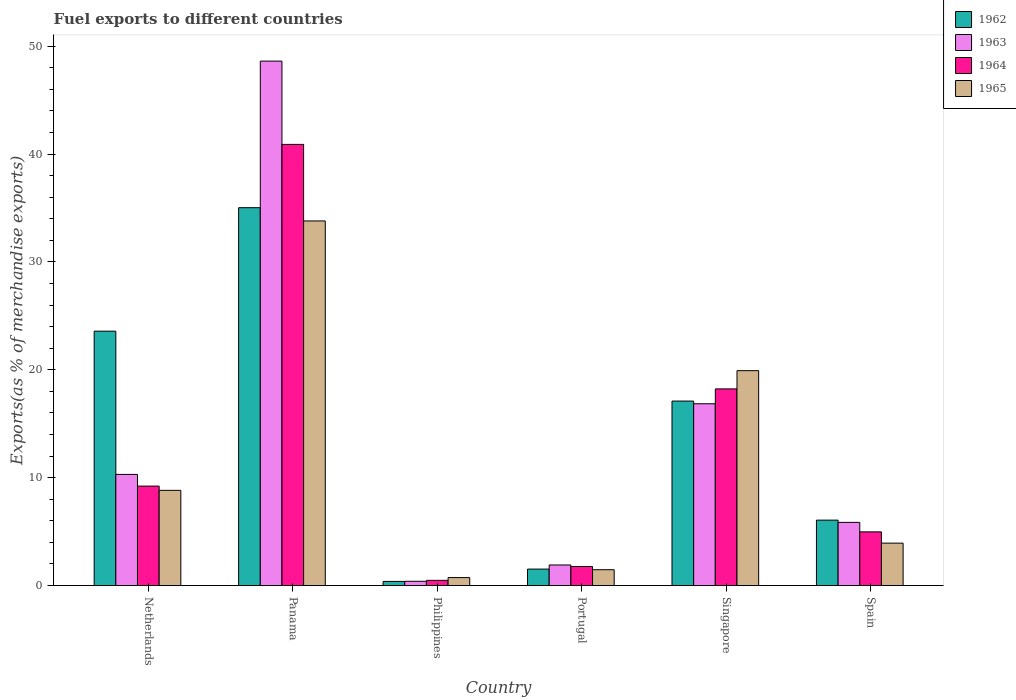How many groups of bars are there?
Your answer should be very brief. 6. Are the number of bars per tick equal to the number of legend labels?
Make the answer very short. Yes. How many bars are there on the 6th tick from the left?
Offer a terse response. 4. What is the label of the 6th group of bars from the left?
Make the answer very short. Spain. What is the percentage of exports to different countries in 1963 in Spain?
Provide a succinct answer. 5.86. Across all countries, what is the maximum percentage of exports to different countries in 1962?
Your answer should be very brief. 35.03. Across all countries, what is the minimum percentage of exports to different countries in 1963?
Keep it short and to the point. 0.4. In which country was the percentage of exports to different countries in 1964 maximum?
Keep it short and to the point. Panama. In which country was the percentage of exports to different countries in 1962 minimum?
Your answer should be very brief. Philippines. What is the total percentage of exports to different countries in 1962 in the graph?
Keep it short and to the point. 83.7. What is the difference between the percentage of exports to different countries in 1965 in Singapore and that in Spain?
Your answer should be very brief. 15.99. What is the difference between the percentage of exports to different countries in 1964 in Portugal and the percentage of exports to different countries in 1965 in Singapore?
Give a very brief answer. -18.16. What is the average percentage of exports to different countries in 1964 per country?
Offer a very short reply. 12.6. What is the difference between the percentage of exports to different countries of/in 1965 and percentage of exports to different countries of/in 1964 in Netherlands?
Ensure brevity in your answer.  -0.39. In how many countries, is the percentage of exports to different countries in 1965 greater than 32 %?
Your response must be concise. 1. What is the ratio of the percentage of exports to different countries in 1963 in Panama to that in Singapore?
Provide a succinct answer. 2.88. Is the difference between the percentage of exports to different countries in 1965 in Philippines and Spain greater than the difference between the percentage of exports to different countries in 1964 in Philippines and Spain?
Make the answer very short. Yes. What is the difference between the highest and the second highest percentage of exports to different countries in 1964?
Give a very brief answer. 31.68. What is the difference between the highest and the lowest percentage of exports to different countries in 1965?
Your response must be concise. 33.06. In how many countries, is the percentage of exports to different countries in 1965 greater than the average percentage of exports to different countries in 1965 taken over all countries?
Your answer should be compact. 2. Is it the case that in every country, the sum of the percentage of exports to different countries in 1962 and percentage of exports to different countries in 1964 is greater than the sum of percentage of exports to different countries in 1965 and percentage of exports to different countries in 1963?
Offer a terse response. No. What does the 3rd bar from the left in Netherlands represents?
Offer a very short reply. 1964. Is it the case that in every country, the sum of the percentage of exports to different countries in 1962 and percentage of exports to different countries in 1964 is greater than the percentage of exports to different countries in 1963?
Your answer should be compact. Yes. How many bars are there?
Your answer should be very brief. 24. What is the difference between two consecutive major ticks on the Y-axis?
Your response must be concise. 10. Does the graph contain grids?
Give a very brief answer. No. What is the title of the graph?
Offer a terse response. Fuel exports to different countries. What is the label or title of the X-axis?
Your answer should be very brief. Country. What is the label or title of the Y-axis?
Your answer should be compact. Exports(as % of merchandise exports). What is the Exports(as % of merchandise exports) in 1962 in Netherlands?
Offer a terse response. 23.58. What is the Exports(as % of merchandise exports) in 1963 in Netherlands?
Your answer should be compact. 10.31. What is the Exports(as % of merchandise exports) in 1964 in Netherlands?
Keep it short and to the point. 9.22. What is the Exports(as % of merchandise exports) of 1965 in Netherlands?
Ensure brevity in your answer.  8.83. What is the Exports(as % of merchandise exports) in 1962 in Panama?
Provide a short and direct response. 35.03. What is the Exports(as % of merchandise exports) of 1963 in Panama?
Provide a short and direct response. 48.62. What is the Exports(as % of merchandise exports) in 1964 in Panama?
Offer a very short reply. 40.9. What is the Exports(as % of merchandise exports) of 1965 in Panama?
Provide a short and direct response. 33.8. What is the Exports(as % of merchandise exports) of 1962 in Philippines?
Your response must be concise. 0.38. What is the Exports(as % of merchandise exports) of 1963 in Philippines?
Offer a terse response. 0.4. What is the Exports(as % of merchandise exports) in 1964 in Philippines?
Your answer should be compact. 0.48. What is the Exports(as % of merchandise exports) of 1965 in Philippines?
Offer a terse response. 0.74. What is the Exports(as % of merchandise exports) in 1962 in Portugal?
Make the answer very short. 1.53. What is the Exports(as % of merchandise exports) of 1963 in Portugal?
Your answer should be very brief. 1.91. What is the Exports(as % of merchandise exports) in 1964 in Portugal?
Provide a succinct answer. 1.77. What is the Exports(as % of merchandise exports) of 1965 in Portugal?
Offer a very short reply. 1.47. What is the Exports(as % of merchandise exports) of 1962 in Singapore?
Your answer should be compact. 17.1. What is the Exports(as % of merchandise exports) in 1963 in Singapore?
Ensure brevity in your answer.  16.85. What is the Exports(as % of merchandise exports) of 1964 in Singapore?
Keep it short and to the point. 18.23. What is the Exports(as % of merchandise exports) in 1965 in Singapore?
Keep it short and to the point. 19.92. What is the Exports(as % of merchandise exports) in 1962 in Spain?
Your response must be concise. 6.07. What is the Exports(as % of merchandise exports) in 1963 in Spain?
Offer a very short reply. 5.86. What is the Exports(as % of merchandise exports) in 1964 in Spain?
Give a very brief answer. 4.98. What is the Exports(as % of merchandise exports) of 1965 in Spain?
Ensure brevity in your answer.  3.93. Across all countries, what is the maximum Exports(as % of merchandise exports) of 1962?
Give a very brief answer. 35.03. Across all countries, what is the maximum Exports(as % of merchandise exports) in 1963?
Your answer should be compact. 48.62. Across all countries, what is the maximum Exports(as % of merchandise exports) in 1964?
Your answer should be very brief. 40.9. Across all countries, what is the maximum Exports(as % of merchandise exports) of 1965?
Keep it short and to the point. 33.8. Across all countries, what is the minimum Exports(as % of merchandise exports) of 1962?
Your answer should be very brief. 0.38. Across all countries, what is the minimum Exports(as % of merchandise exports) in 1963?
Provide a succinct answer. 0.4. Across all countries, what is the minimum Exports(as % of merchandise exports) of 1964?
Give a very brief answer. 0.48. Across all countries, what is the minimum Exports(as % of merchandise exports) of 1965?
Provide a short and direct response. 0.74. What is the total Exports(as % of merchandise exports) in 1962 in the graph?
Give a very brief answer. 83.7. What is the total Exports(as % of merchandise exports) in 1963 in the graph?
Your answer should be very brief. 83.94. What is the total Exports(as % of merchandise exports) in 1964 in the graph?
Your response must be concise. 75.58. What is the total Exports(as % of merchandise exports) of 1965 in the graph?
Ensure brevity in your answer.  68.69. What is the difference between the Exports(as % of merchandise exports) in 1962 in Netherlands and that in Panama?
Provide a succinct answer. -11.45. What is the difference between the Exports(as % of merchandise exports) in 1963 in Netherlands and that in Panama?
Make the answer very short. -38.32. What is the difference between the Exports(as % of merchandise exports) of 1964 in Netherlands and that in Panama?
Provide a succinct answer. -31.68. What is the difference between the Exports(as % of merchandise exports) in 1965 in Netherlands and that in Panama?
Your answer should be very brief. -24.98. What is the difference between the Exports(as % of merchandise exports) in 1962 in Netherlands and that in Philippines?
Provide a succinct answer. 23.2. What is the difference between the Exports(as % of merchandise exports) in 1963 in Netherlands and that in Philippines?
Offer a very short reply. 9.91. What is the difference between the Exports(as % of merchandise exports) of 1964 in Netherlands and that in Philippines?
Keep it short and to the point. 8.74. What is the difference between the Exports(as % of merchandise exports) in 1965 in Netherlands and that in Philippines?
Provide a succinct answer. 8.09. What is the difference between the Exports(as % of merchandise exports) in 1962 in Netherlands and that in Portugal?
Provide a short and direct response. 22.06. What is the difference between the Exports(as % of merchandise exports) of 1963 in Netherlands and that in Portugal?
Your answer should be compact. 8.4. What is the difference between the Exports(as % of merchandise exports) in 1964 in Netherlands and that in Portugal?
Your response must be concise. 7.45. What is the difference between the Exports(as % of merchandise exports) of 1965 in Netherlands and that in Portugal?
Make the answer very short. 7.36. What is the difference between the Exports(as % of merchandise exports) of 1962 in Netherlands and that in Singapore?
Your answer should be compact. 6.48. What is the difference between the Exports(as % of merchandise exports) of 1963 in Netherlands and that in Singapore?
Offer a very short reply. -6.55. What is the difference between the Exports(as % of merchandise exports) of 1964 in Netherlands and that in Singapore?
Give a very brief answer. -9.01. What is the difference between the Exports(as % of merchandise exports) of 1965 in Netherlands and that in Singapore?
Offer a very short reply. -11.1. What is the difference between the Exports(as % of merchandise exports) in 1962 in Netherlands and that in Spain?
Provide a short and direct response. 17.52. What is the difference between the Exports(as % of merchandise exports) of 1963 in Netherlands and that in Spain?
Ensure brevity in your answer.  4.45. What is the difference between the Exports(as % of merchandise exports) in 1964 in Netherlands and that in Spain?
Provide a succinct answer. 4.24. What is the difference between the Exports(as % of merchandise exports) in 1965 in Netherlands and that in Spain?
Ensure brevity in your answer.  4.89. What is the difference between the Exports(as % of merchandise exports) of 1962 in Panama and that in Philippines?
Give a very brief answer. 34.65. What is the difference between the Exports(as % of merchandise exports) in 1963 in Panama and that in Philippines?
Provide a succinct answer. 48.22. What is the difference between the Exports(as % of merchandise exports) of 1964 in Panama and that in Philippines?
Give a very brief answer. 40.41. What is the difference between the Exports(as % of merchandise exports) of 1965 in Panama and that in Philippines?
Your response must be concise. 33.06. What is the difference between the Exports(as % of merchandise exports) in 1962 in Panama and that in Portugal?
Make the answer very short. 33.5. What is the difference between the Exports(as % of merchandise exports) in 1963 in Panama and that in Portugal?
Your answer should be very brief. 46.71. What is the difference between the Exports(as % of merchandise exports) in 1964 in Panama and that in Portugal?
Make the answer very short. 39.13. What is the difference between the Exports(as % of merchandise exports) in 1965 in Panama and that in Portugal?
Give a very brief answer. 32.33. What is the difference between the Exports(as % of merchandise exports) in 1962 in Panama and that in Singapore?
Offer a very short reply. 17.93. What is the difference between the Exports(as % of merchandise exports) in 1963 in Panama and that in Singapore?
Your answer should be very brief. 31.77. What is the difference between the Exports(as % of merchandise exports) of 1964 in Panama and that in Singapore?
Make the answer very short. 22.67. What is the difference between the Exports(as % of merchandise exports) in 1965 in Panama and that in Singapore?
Keep it short and to the point. 13.88. What is the difference between the Exports(as % of merchandise exports) of 1962 in Panama and that in Spain?
Provide a succinct answer. 28.96. What is the difference between the Exports(as % of merchandise exports) in 1963 in Panama and that in Spain?
Provide a short and direct response. 42.76. What is the difference between the Exports(as % of merchandise exports) of 1964 in Panama and that in Spain?
Your answer should be compact. 35.92. What is the difference between the Exports(as % of merchandise exports) in 1965 in Panama and that in Spain?
Keep it short and to the point. 29.87. What is the difference between the Exports(as % of merchandise exports) of 1962 in Philippines and that in Portugal?
Keep it short and to the point. -1.14. What is the difference between the Exports(as % of merchandise exports) of 1963 in Philippines and that in Portugal?
Your answer should be compact. -1.51. What is the difference between the Exports(as % of merchandise exports) in 1964 in Philippines and that in Portugal?
Your response must be concise. -1.28. What is the difference between the Exports(as % of merchandise exports) in 1965 in Philippines and that in Portugal?
Your answer should be very brief. -0.73. What is the difference between the Exports(as % of merchandise exports) of 1962 in Philippines and that in Singapore?
Make the answer very short. -16.72. What is the difference between the Exports(as % of merchandise exports) in 1963 in Philippines and that in Singapore?
Provide a short and direct response. -16.46. What is the difference between the Exports(as % of merchandise exports) of 1964 in Philippines and that in Singapore?
Offer a terse response. -17.75. What is the difference between the Exports(as % of merchandise exports) in 1965 in Philippines and that in Singapore?
Provide a short and direct response. -19.18. What is the difference between the Exports(as % of merchandise exports) of 1962 in Philippines and that in Spain?
Offer a terse response. -5.68. What is the difference between the Exports(as % of merchandise exports) of 1963 in Philippines and that in Spain?
Keep it short and to the point. -5.46. What is the difference between the Exports(as % of merchandise exports) of 1964 in Philippines and that in Spain?
Your answer should be very brief. -4.49. What is the difference between the Exports(as % of merchandise exports) in 1965 in Philippines and that in Spain?
Your response must be concise. -3.19. What is the difference between the Exports(as % of merchandise exports) in 1962 in Portugal and that in Singapore?
Offer a very short reply. -15.58. What is the difference between the Exports(as % of merchandise exports) in 1963 in Portugal and that in Singapore?
Keep it short and to the point. -14.95. What is the difference between the Exports(as % of merchandise exports) of 1964 in Portugal and that in Singapore?
Offer a very short reply. -16.47. What is the difference between the Exports(as % of merchandise exports) in 1965 in Portugal and that in Singapore?
Provide a succinct answer. -18.45. What is the difference between the Exports(as % of merchandise exports) in 1962 in Portugal and that in Spain?
Offer a very short reply. -4.54. What is the difference between the Exports(as % of merchandise exports) in 1963 in Portugal and that in Spain?
Your answer should be compact. -3.95. What is the difference between the Exports(as % of merchandise exports) of 1964 in Portugal and that in Spain?
Provide a short and direct response. -3.21. What is the difference between the Exports(as % of merchandise exports) of 1965 in Portugal and that in Spain?
Ensure brevity in your answer.  -2.46. What is the difference between the Exports(as % of merchandise exports) in 1962 in Singapore and that in Spain?
Offer a terse response. 11.04. What is the difference between the Exports(as % of merchandise exports) in 1963 in Singapore and that in Spain?
Offer a terse response. 11. What is the difference between the Exports(as % of merchandise exports) of 1964 in Singapore and that in Spain?
Your answer should be compact. 13.25. What is the difference between the Exports(as % of merchandise exports) of 1965 in Singapore and that in Spain?
Your answer should be very brief. 15.99. What is the difference between the Exports(as % of merchandise exports) in 1962 in Netherlands and the Exports(as % of merchandise exports) in 1963 in Panama?
Offer a very short reply. -25.04. What is the difference between the Exports(as % of merchandise exports) in 1962 in Netherlands and the Exports(as % of merchandise exports) in 1964 in Panama?
Offer a very short reply. -17.31. What is the difference between the Exports(as % of merchandise exports) of 1962 in Netherlands and the Exports(as % of merchandise exports) of 1965 in Panama?
Offer a very short reply. -10.22. What is the difference between the Exports(as % of merchandise exports) of 1963 in Netherlands and the Exports(as % of merchandise exports) of 1964 in Panama?
Ensure brevity in your answer.  -30.59. What is the difference between the Exports(as % of merchandise exports) of 1963 in Netherlands and the Exports(as % of merchandise exports) of 1965 in Panama?
Ensure brevity in your answer.  -23.5. What is the difference between the Exports(as % of merchandise exports) of 1964 in Netherlands and the Exports(as % of merchandise exports) of 1965 in Panama?
Give a very brief answer. -24.58. What is the difference between the Exports(as % of merchandise exports) of 1962 in Netherlands and the Exports(as % of merchandise exports) of 1963 in Philippines?
Your response must be concise. 23.19. What is the difference between the Exports(as % of merchandise exports) of 1962 in Netherlands and the Exports(as % of merchandise exports) of 1964 in Philippines?
Ensure brevity in your answer.  23.1. What is the difference between the Exports(as % of merchandise exports) of 1962 in Netherlands and the Exports(as % of merchandise exports) of 1965 in Philippines?
Give a very brief answer. 22.84. What is the difference between the Exports(as % of merchandise exports) in 1963 in Netherlands and the Exports(as % of merchandise exports) in 1964 in Philippines?
Make the answer very short. 9.82. What is the difference between the Exports(as % of merchandise exports) of 1963 in Netherlands and the Exports(as % of merchandise exports) of 1965 in Philippines?
Keep it short and to the point. 9.57. What is the difference between the Exports(as % of merchandise exports) of 1964 in Netherlands and the Exports(as % of merchandise exports) of 1965 in Philippines?
Keep it short and to the point. 8.48. What is the difference between the Exports(as % of merchandise exports) in 1962 in Netherlands and the Exports(as % of merchandise exports) in 1963 in Portugal?
Offer a very short reply. 21.68. What is the difference between the Exports(as % of merchandise exports) of 1962 in Netherlands and the Exports(as % of merchandise exports) of 1964 in Portugal?
Give a very brief answer. 21.82. What is the difference between the Exports(as % of merchandise exports) of 1962 in Netherlands and the Exports(as % of merchandise exports) of 1965 in Portugal?
Offer a terse response. 22.11. What is the difference between the Exports(as % of merchandise exports) of 1963 in Netherlands and the Exports(as % of merchandise exports) of 1964 in Portugal?
Offer a very short reply. 8.54. What is the difference between the Exports(as % of merchandise exports) of 1963 in Netherlands and the Exports(as % of merchandise exports) of 1965 in Portugal?
Your answer should be compact. 8.84. What is the difference between the Exports(as % of merchandise exports) of 1964 in Netherlands and the Exports(as % of merchandise exports) of 1965 in Portugal?
Ensure brevity in your answer.  7.75. What is the difference between the Exports(as % of merchandise exports) of 1962 in Netherlands and the Exports(as % of merchandise exports) of 1963 in Singapore?
Your answer should be compact. 6.73. What is the difference between the Exports(as % of merchandise exports) in 1962 in Netherlands and the Exports(as % of merchandise exports) in 1964 in Singapore?
Provide a short and direct response. 5.35. What is the difference between the Exports(as % of merchandise exports) in 1962 in Netherlands and the Exports(as % of merchandise exports) in 1965 in Singapore?
Provide a short and direct response. 3.66. What is the difference between the Exports(as % of merchandise exports) in 1963 in Netherlands and the Exports(as % of merchandise exports) in 1964 in Singapore?
Provide a short and direct response. -7.93. What is the difference between the Exports(as % of merchandise exports) of 1963 in Netherlands and the Exports(as % of merchandise exports) of 1965 in Singapore?
Make the answer very short. -9.62. What is the difference between the Exports(as % of merchandise exports) of 1964 in Netherlands and the Exports(as % of merchandise exports) of 1965 in Singapore?
Your answer should be very brief. -10.7. What is the difference between the Exports(as % of merchandise exports) of 1962 in Netherlands and the Exports(as % of merchandise exports) of 1963 in Spain?
Give a very brief answer. 17.73. What is the difference between the Exports(as % of merchandise exports) of 1962 in Netherlands and the Exports(as % of merchandise exports) of 1964 in Spain?
Provide a short and direct response. 18.61. What is the difference between the Exports(as % of merchandise exports) in 1962 in Netherlands and the Exports(as % of merchandise exports) in 1965 in Spain?
Provide a succinct answer. 19.65. What is the difference between the Exports(as % of merchandise exports) in 1963 in Netherlands and the Exports(as % of merchandise exports) in 1964 in Spain?
Provide a short and direct response. 5.33. What is the difference between the Exports(as % of merchandise exports) of 1963 in Netherlands and the Exports(as % of merchandise exports) of 1965 in Spain?
Keep it short and to the point. 6.37. What is the difference between the Exports(as % of merchandise exports) of 1964 in Netherlands and the Exports(as % of merchandise exports) of 1965 in Spain?
Give a very brief answer. 5.29. What is the difference between the Exports(as % of merchandise exports) of 1962 in Panama and the Exports(as % of merchandise exports) of 1963 in Philippines?
Keep it short and to the point. 34.63. What is the difference between the Exports(as % of merchandise exports) of 1962 in Panama and the Exports(as % of merchandise exports) of 1964 in Philippines?
Offer a terse response. 34.55. What is the difference between the Exports(as % of merchandise exports) in 1962 in Panama and the Exports(as % of merchandise exports) in 1965 in Philippines?
Offer a very short reply. 34.29. What is the difference between the Exports(as % of merchandise exports) of 1963 in Panama and the Exports(as % of merchandise exports) of 1964 in Philippines?
Ensure brevity in your answer.  48.14. What is the difference between the Exports(as % of merchandise exports) of 1963 in Panama and the Exports(as % of merchandise exports) of 1965 in Philippines?
Your response must be concise. 47.88. What is the difference between the Exports(as % of merchandise exports) of 1964 in Panama and the Exports(as % of merchandise exports) of 1965 in Philippines?
Your answer should be compact. 40.16. What is the difference between the Exports(as % of merchandise exports) in 1962 in Panama and the Exports(as % of merchandise exports) in 1963 in Portugal?
Ensure brevity in your answer.  33.12. What is the difference between the Exports(as % of merchandise exports) of 1962 in Panama and the Exports(as % of merchandise exports) of 1964 in Portugal?
Offer a terse response. 33.26. What is the difference between the Exports(as % of merchandise exports) of 1962 in Panama and the Exports(as % of merchandise exports) of 1965 in Portugal?
Keep it short and to the point. 33.56. What is the difference between the Exports(as % of merchandise exports) in 1963 in Panama and the Exports(as % of merchandise exports) in 1964 in Portugal?
Offer a very short reply. 46.85. What is the difference between the Exports(as % of merchandise exports) of 1963 in Panama and the Exports(as % of merchandise exports) of 1965 in Portugal?
Offer a terse response. 47.15. What is the difference between the Exports(as % of merchandise exports) of 1964 in Panama and the Exports(as % of merchandise exports) of 1965 in Portugal?
Make the answer very short. 39.43. What is the difference between the Exports(as % of merchandise exports) in 1962 in Panama and the Exports(as % of merchandise exports) in 1963 in Singapore?
Offer a terse response. 18.18. What is the difference between the Exports(as % of merchandise exports) of 1962 in Panama and the Exports(as % of merchandise exports) of 1964 in Singapore?
Offer a very short reply. 16.8. What is the difference between the Exports(as % of merchandise exports) of 1962 in Panama and the Exports(as % of merchandise exports) of 1965 in Singapore?
Provide a succinct answer. 15.11. What is the difference between the Exports(as % of merchandise exports) in 1963 in Panama and the Exports(as % of merchandise exports) in 1964 in Singapore?
Provide a short and direct response. 30.39. What is the difference between the Exports(as % of merchandise exports) in 1963 in Panama and the Exports(as % of merchandise exports) in 1965 in Singapore?
Provide a short and direct response. 28.7. What is the difference between the Exports(as % of merchandise exports) in 1964 in Panama and the Exports(as % of merchandise exports) in 1965 in Singapore?
Make the answer very short. 20.98. What is the difference between the Exports(as % of merchandise exports) of 1962 in Panama and the Exports(as % of merchandise exports) of 1963 in Spain?
Provide a short and direct response. 29.17. What is the difference between the Exports(as % of merchandise exports) of 1962 in Panama and the Exports(as % of merchandise exports) of 1964 in Spain?
Offer a terse response. 30.05. What is the difference between the Exports(as % of merchandise exports) of 1962 in Panama and the Exports(as % of merchandise exports) of 1965 in Spain?
Make the answer very short. 31.1. What is the difference between the Exports(as % of merchandise exports) of 1963 in Panama and the Exports(as % of merchandise exports) of 1964 in Spain?
Provide a short and direct response. 43.64. What is the difference between the Exports(as % of merchandise exports) of 1963 in Panama and the Exports(as % of merchandise exports) of 1965 in Spain?
Offer a very short reply. 44.69. What is the difference between the Exports(as % of merchandise exports) of 1964 in Panama and the Exports(as % of merchandise exports) of 1965 in Spain?
Your answer should be compact. 36.96. What is the difference between the Exports(as % of merchandise exports) in 1962 in Philippines and the Exports(as % of merchandise exports) in 1963 in Portugal?
Your response must be concise. -1.52. What is the difference between the Exports(as % of merchandise exports) in 1962 in Philippines and the Exports(as % of merchandise exports) in 1964 in Portugal?
Offer a terse response. -1.38. What is the difference between the Exports(as % of merchandise exports) of 1962 in Philippines and the Exports(as % of merchandise exports) of 1965 in Portugal?
Give a very brief answer. -1.08. What is the difference between the Exports(as % of merchandise exports) in 1963 in Philippines and the Exports(as % of merchandise exports) in 1964 in Portugal?
Your answer should be very brief. -1.37. What is the difference between the Exports(as % of merchandise exports) of 1963 in Philippines and the Exports(as % of merchandise exports) of 1965 in Portugal?
Keep it short and to the point. -1.07. What is the difference between the Exports(as % of merchandise exports) in 1964 in Philippines and the Exports(as % of merchandise exports) in 1965 in Portugal?
Give a very brief answer. -0.99. What is the difference between the Exports(as % of merchandise exports) in 1962 in Philippines and the Exports(as % of merchandise exports) in 1963 in Singapore?
Your response must be concise. -16.47. What is the difference between the Exports(as % of merchandise exports) of 1962 in Philippines and the Exports(as % of merchandise exports) of 1964 in Singapore?
Make the answer very short. -17.85. What is the difference between the Exports(as % of merchandise exports) in 1962 in Philippines and the Exports(as % of merchandise exports) in 1965 in Singapore?
Keep it short and to the point. -19.54. What is the difference between the Exports(as % of merchandise exports) in 1963 in Philippines and the Exports(as % of merchandise exports) in 1964 in Singapore?
Make the answer very short. -17.84. What is the difference between the Exports(as % of merchandise exports) in 1963 in Philippines and the Exports(as % of merchandise exports) in 1965 in Singapore?
Offer a very short reply. -19.53. What is the difference between the Exports(as % of merchandise exports) in 1964 in Philippines and the Exports(as % of merchandise exports) in 1965 in Singapore?
Provide a succinct answer. -19.44. What is the difference between the Exports(as % of merchandise exports) of 1962 in Philippines and the Exports(as % of merchandise exports) of 1963 in Spain?
Offer a very short reply. -5.47. What is the difference between the Exports(as % of merchandise exports) in 1962 in Philippines and the Exports(as % of merchandise exports) in 1964 in Spain?
Your answer should be very brief. -4.59. What is the difference between the Exports(as % of merchandise exports) of 1962 in Philippines and the Exports(as % of merchandise exports) of 1965 in Spain?
Give a very brief answer. -3.55. What is the difference between the Exports(as % of merchandise exports) in 1963 in Philippines and the Exports(as % of merchandise exports) in 1964 in Spain?
Your response must be concise. -4.58. What is the difference between the Exports(as % of merchandise exports) in 1963 in Philippines and the Exports(as % of merchandise exports) in 1965 in Spain?
Your answer should be compact. -3.54. What is the difference between the Exports(as % of merchandise exports) in 1964 in Philippines and the Exports(as % of merchandise exports) in 1965 in Spain?
Your answer should be very brief. -3.45. What is the difference between the Exports(as % of merchandise exports) in 1962 in Portugal and the Exports(as % of merchandise exports) in 1963 in Singapore?
Ensure brevity in your answer.  -15.33. What is the difference between the Exports(as % of merchandise exports) in 1962 in Portugal and the Exports(as % of merchandise exports) in 1964 in Singapore?
Offer a very short reply. -16.7. What is the difference between the Exports(as % of merchandise exports) of 1962 in Portugal and the Exports(as % of merchandise exports) of 1965 in Singapore?
Your response must be concise. -18.39. What is the difference between the Exports(as % of merchandise exports) of 1963 in Portugal and the Exports(as % of merchandise exports) of 1964 in Singapore?
Offer a terse response. -16.32. What is the difference between the Exports(as % of merchandise exports) of 1963 in Portugal and the Exports(as % of merchandise exports) of 1965 in Singapore?
Offer a terse response. -18.01. What is the difference between the Exports(as % of merchandise exports) of 1964 in Portugal and the Exports(as % of merchandise exports) of 1965 in Singapore?
Provide a short and direct response. -18.16. What is the difference between the Exports(as % of merchandise exports) in 1962 in Portugal and the Exports(as % of merchandise exports) in 1963 in Spain?
Provide a succinct answer. -4.33. What is the difference between the Exports(as % of merchandise exports) of 1962 in Portugal and the Exports(as % of merchandise exports) of 1964 in Spain?
Give a very brief answer. -3.45. What is the difference between the Exports(as % of merchandise exports) in 1962 in Portugal and the Exports(as % of merchandise exports) in 1965 in Spain?
Make the answer very short. -2.41. What is the difference between the Exports(as % of merchandise exports) in 1963 in Portugal and the Exports(as % of merchandise exports) in 1964 in Spain?
Provide a short and direct response. -3.07. What is the difference between the Exports(as % of merchandise exports) of 1963 in Portugal and the Exports(as % of merchandise exports) of 1965 in Spain?
Make the answer very short. -2.03. What is the difference between the Exports(as % of merchandise exports) in 1964 in Portugal and the Exports(as % of merchandise exports) in 1965 in Spain?
Your response must be concise. -2.17. What is the difference between the Exports(as % of merchandise exports) in 1962 in Singapore and the Exports(as % of merchandise exports) in 1963 in Spain?
Offer a terse response. 11.25. What is the difference between the Exports(as % of merchandise exports) in 1962 in Singapore and the Exports(as % of merchandise exports) in 1964 in Spain?
Make the answer very short. 12.13. What is the difference between the Exports(as % of merchandise exports) of 1962 in Singapore and the Exports(as % of merchandise exports) of 1965 in Spain?
Your answer should be very brief. 13.17. What is the difference between the Exports(as % of merchandise exports) of 1963 in Singapore and the Exports(as % of merchandise exports) of 1964 in Spain?
Offer a very short reply. 11.88. What is the difference between the Exports(as % of merchandise exports) of 1963 in Singapore and the Exports(as % of merchandise exports) of 1965 in Spain?
Ensure brevity in your answer.  12.92. What is the difference between the Exports(as % of merchandise exports) of 1964 in Singapore and the Exports(as % of merchandise exports) of 1965 in Spain?
Offer a terse response. 14.3. What is the average Exports(as % of merchandise exports) of 1962 per country?
Make the answer very short. 13.95. What is the average Exports(as % of merchandise exports) of 1963 per country?
Your answer should be compact. 13.99. What is the average Exports(as % of merchandise exports) of 1964 per country?
Keep it short and to the point. 12.6. What is the average Exports(as % of merchandise exports) in 1965 per country?
Your response must be concise. 11.45. What is the difference between the Exports(as % of merchandise exports) of 1962 and Exports(as % of merchandise exports) of 1963 in Netherlands?
Your response must be concise. 13.28. What is the difference between the Exports(as % of merchandise exports) in 1962 and Exports(as % of merchandise exports) in 1964 in Netherlands?
Offer a very short reply. 14.36. What is the difference between the Exports(as % of merchandise exports) in 1962 and Exports(as % of merchandise exports) in 1965 in Netherlands?
Provide a short and direct response. 14.76. What is the difference between the Exports(as % of merchandise exports) of 1963 and Exports(as % of merchandise exports) of 1964 in Netherlands?
Make the answer very short. 1.09. What is the difference between the Exports(as % of merchandise exports) of 1963 and Exports(as % of merchandise exports) of 1965 in Netherlands?
Offer a terse response. 1.48. What is the difference between the Exports(as % of merchandise exports) in 1964 and Exports(as % of merchandise exports) in 1965 in Netherlands?
Offer a terse response. 0.39. What is the difference between the Exports(as % of merchandise exports) of 1962 and Exports(as % of merchandise exports) of 1963 in Panama?
Your answer should be very brief. -13.59. What is the difference between the Exports(as % of merchandise exports) in 1962 and Exports(as % of merchandise exports) in 1964 in Panama?
Provide a short and direct response. -5.87. What is the difference between the Exports(as % of merchandise exports) in 1962 and Exports(as % of merchandise exports) in 1965 in Panama?
Provide a succinct answer. 1.23. What is the difference between the Exports(as % of merchandise exports) in 1963 and Exports(as % of merchandise exports) in 1964 in Panama?
Ensure brevity in your answer.  7.72. What is the difference between the Exports(as % of merchandise exports) in 1963 and Exports(as % of merchandise exports) in 1965 in Panama?
Offer a terse response. 14.82. What is the difference between the Exports(as % of merchandise exports) of 1964 and Exports(as % of merchandise exports) of 1965 in Panama?
Keep it short and to the point. 7.1. What is the difference between the Exports(as % of merchandise exports) of 1962 and Exports(as % of merchandise exports) of 1963 in Philippines?
Your response must be concise. -0.01. What is the difference between the Exports(as % of merchandise exports) in 1962 and Exports(as % of merchandise exports) in 1964 in Philippines?
Provide a succinct answer. -0.1. What is the difference between the Exports(as % of merchandise exports) of 1962 and Exports(as % of merchandise exports) of 1965 in Philippines?
Offer a very short reply. -0.35. What is the difference between the Exports(as % of merchandise exports) of 1963 and Exports(as % of merchandise exports) of 1964 in Philippines?
Your response must be concise. -0.09. What is the difference between the Exports(as % of merchandise exports) in 1963 and Exports(as % of merchandise exports) in 1965 in Philippines?
Provide a succinct answer. -0.34. What is the difference between the Exports(as % of merchandise exports) in 1964 and Exports(as % of merchandise exports) in 1965 in Philippines?
Give a very brief answer. -0.26. What is the difference between the Exports(as % of merchandise exports) in 1962 and Exports(as % of merchandise exports) in 1963 in Portugal?
Your answer should be very brief. -0.38. What is the difference between the Exports(as % of merchandise exports) in 1962 and Exports(as % of merchandise exports) in 1964 in Portugal?
Keep it short and to the point. -0.24. What is the difference between the Exports(as % of merchandise exports) in 1962 and Exports(as % of merchandise exports) in 1965 in Portugal?
Your response must be concise. 0.06. What is the difference between the Exports(as % of merchandise exports) of 1963 and Exports(as % of merchandise exports) of 1964 in Portugal?
Give a very brief answer. 0.14. What is the difference between the Exports(as % of merchandise exports) in 1963 and Exports(as % of merchandise exports) in 1965 in Portugal?
Your answer should be very brief. 0.44. What is the difference between the Exports(as % of merchandise exports) in 1964 and Exports(as % of merchandise exports) in 1965 in Portugal?
Provide a short and direct response. 0.3. What is the difference between the Exports(as % of merchandise exports) of 1962 and Exports(as % of merchandise exports) of 1963 in Singapore?
Your answer should be very brief. 0.25. What is the difference between the Exports(as % of merchandise exports) of 1962 and Exports(as % of merchandise exports) of 1964 in Singapore?
Provide a succinct answer. -1.13. What is the difference between the Exports(as % of merchandise exports) of 1962 and Exports(as % of merchandise exports) of 1965 in Singapore?
Keep it short and to the point. -2.82. What is the difference between the Exports(as % of merchandise exports) in 1963 and Exports(as % of merchandise exports) in 1964 in Singapore?
Make the answer very short. -1.38. What is the difference between the Exports(as % of merchandise exports) in 1963 and Exports(as % of merchandise exports) in 1965 in Singapore?
Your answer should be very brief. -3.07. What is the difference between the Exports(as % of merchandise exports) in 1964 and Exports(as % of merchandise exports) in 1965 in Singapore?
Give a very brief answer. -1.69. What is the difference between the Exports(as % of merchandise exports) in 1962 and Exports(as % of merchandise exports) in 1963 in Spain?
Offer a very short reply. 0.21. What is the difference between the Exports(as % of merchandise exports) in 1962 and Exports(as % of merchandise exports) in 1964 in Spain?
Provide a short and direct response. 1.09. What is the difference between the Exports(as % of merchandise exports) in 1962 and Exports(as % of merchandise exports) in 1965 in Spain?
Provide a short and direct response. 2.13. What is the difference between the Exports(as % of merchandise exports) in 1963 and Exports(as % of merchandise exports) in 1964 in Spain?
Ensure brevity in your answer.  0.88. What is the difference between the Exports(as % of merchandise exports) in 1963 and Exports(as % of merchandise exports) in 1965 in Spain?
Give a very brief answer. 1.92. What is the difference between the Exports(as % of merchandise exports) in 1964 and Exports(as % of merchandise exports) in 1965 in Spain?
Ensure brevity in your answer.  1.04. What is the ratio of the Exports(as % of merchandise exports) in 1962 in Netherlands to that in Panama?
Your response must be concise. 0.67. What is the ratio of the Exports(as % of merchandise exports) in 1963 in Netherlands to that in Panama?
Give a very brief answer. 0.21. What is the ratio of the Exports(as % of merchandise exports) of 1964 in Netherlands to that in Panama?
Your response must be concise. 0.23. What is the ratio of the Exports(as % of merchandise exports) in 1965 in Netherlands to that in Panama?
Provide a succinct answer. 0.26. What is the ratio of the Exports(as % of merchandise exports) in 1962 in Netherlands to that in Philippines?
Your answer should be very brief. 61.27. What is the ratio of the Exports(as % of merchandise exports) in 1963 in Netherlands to that in Philippines?
Provide a short and direct response. 26.03. What is the ratio of the Exports(as % of merchandise exports) in 1964 in Netherlands to that in Philippines?
Offer a very short reply. 19.07. What is the ratio of the Exports(as % of merchandise exports) of 1965 in Netherlands to that in Philippines?
Make the answer very short. 11.93. What is the ratio of the Exports(as % of merchandise exports) in 1962 in Netherlands to that in Portugal?
Ensure brevity in your answer.  15.43. What is the ratio of the Exports(as % of merchandise exports) of 1963 in Netherlands to that in Portugal?
Provide a short and direct response. 5.4. What is the ratio of the Exports(as % of merchandise exports) of 1964 in Netherlands to that in Portugal?
Give a very brief answer. 5.22. What is the ratio of the Exports(as % of merchandise exports) of 1965 in Netherlands to that in Portugal?
Offer a very short reply. 6.01. What is the ratio of the Exports(as % of merchandise exports) in 1962 in Netherlands to that in Singapore?
Your response must be concise. 1.38. What is the ratio of the Exports(as % of merchandise exports) of 1963 in Netherlands to that in Singapore?
Your answer should be compact. 0.61. What is the ratio of the Exports(as % of merchandise exports) of 1964 in Netherlands to that in Singapore?
Your answer should be compact. 0.51. What is the ratio of the Exports(as % of merchandise exports) of 1965 in Netherlands to that in Singapore?
Offer a very short reply. 0.44. What is the ratio of the Exports(as % of merchandise exports) in 1962 in Netherlands to that in Spain?
Provide a succinct answer. 3.89. What is the ratio of the Exports(as % of merchandise exports) in 1963 in Netherlands to that in Spain?
Make the answer very short. 1.76. What is the ratio of the Exports(as % of merchandise exports) of 1964 in Netherlands to that in Spain?
Your answer should be compact. 1.85. What is the ratio of the Exports(as % of merchandise exports) in 1965 in Netherlands to that in Spain?
Offer a terse response. 2.24. What is the ratio of the Exports(as % of merchandise exports) of 1962 in Panama to that in Philippines?
Your response must be concise. 91.01. What is the ratio of the Exports(as % of merchandise exports) of 1963 in Panama to that in Philippines?
Your response must be concise. 122.82. What is the ratio of the Exports(as % of merchandise exports) in 1964 in Panama to that in Philippines?
Keep it short and to the point. 84.6. What is the ratio of the Exports(as % of merchandise exports) of 1965 in Panama to that in Philippines?
Your answer should be compact. 45.69. What is the ratio of the Exports(as % of merchandise exports) in 1962 in Panama to that in Portugal?
Your answer should be compact. 22.92. What is the ratio of the Exports(as % of merchandise exports) in 1963 in Panama to that in Portugal?
Make the answer very short. 25.47. What is the ratio of the Exports(as % of merchandise exports) of 1964 in Panama to that in Portugal?
Provide a short and direct response. 23.15. What is the ratio of the Exports(as % of merchandise exports) of 1965 in Panama to that in Portugal?
Make the answer very short. 23. What is the ratio of the Exports(as % of merchandise exports) in 1962 in Panama to that in Singapore?
Your response must be concise. 2.05. What is the ratio of the Exports(as % of merchandise exports) in 1963 in Panama to that in Singapore?
Your answer should be very brief. 2.88. What is the ratio of the Exports(as % of merchandise exports) in 1964 in Panama to that in Singapore?
Provide a short and direct response. 2.24. What is the ratio of the Exports(as % of merchandise exports) of 1965 in Panama to that in Singapore?
Provide a short and direct response. 1.7. What is the ratio of the Exports(as % of merchandise exports) of 1962 in Panama to that in Spain?
Your answer should be compact. 5.77. What is the ratio of the Exports(as % of merchandise exports) of 1963 in Panama to that in Spain?
Offer a very short reply. 8.3. What is the ratio of the Exports(as % of merchandise exports) in 1964 in Panama to that in Spain?
Your answer should be very brief. 8.22. What is the ratio of the Exports(as % of merchandise exports) of 1965 in Panama to that in Spain?
Offer a very short reply. 8.59. What is the ratio of the Exports(as % of merchandise exports) in 1962 in Philippines to that in Portugal?
Provide a short and direct response. 0.25. What is the ratio of the Exports(as % of merchandise exports) in 1963 in Philippines to that in Portugal?
Offer a terse response. 0.21. What is the ratio of the Exports(as % of merchandise exports) in 1964 in Philippines to that in Portugal?
Your answer should be compact. 0.27. What is the ratio of the Exports(as % of merchandise exports) of 1965 in Philippines to that in Portugal?
Your answer should be very brief. 0.5. What is the ratio of the Exports(as % of merchandise exports) in 1962 in Philippines to that in Singapore?
Make the answer very short. 0.02. What is the ratio of the Exports(as % of merchandise exports) of 1963 in Philippines to that in Singapore?
Ensure brevity in your answer.  0.02. What is the ratio of the Exports(as % of merchandise exports) in 1964 in Philippines to that in Singapore?
Offer a very short reply. 0.03. What is the ratio of the Exports(as % of merchandise exports) of 1965 in Philippines to that in Singapore?
Your answer should be very brief. 0.04. What is the ratio of the Exports(as % of merchandise exports) of 1962 in Philippines to that in Spain?
Offer a very short reply. 0.06. What is the ratio of the Exports(as % of merchandise exports) of 1963 in Philippines to that in Spain?
Your response must be concise. 0.07. What is the ratio of the Exports(as % of merchandise exports) of 1964 in Philippines to that in Spain?
Ensure brevity in your answer.  0.1. What is the ratio of the Exports(as % of merchandise exports) in 1965 in Philippines to that in Spain?
Offer a very short reply. 0.19. What is the ratio of the Exports(as % of merchandise exports) in 1962 in Portugal to that in Singapore?
Your answer should be very brief. 0.09. What is the ratio of the Exports(as % of merchandise exports) of 1963 in Portugal to that in Singapore?
Ensure brevity in your answer.  0.11. What is the ratio of the Exports(as % of merchandise exports) in 1964 in Portugal to that in Singapore?
Keep it short and to the point. 0.1. What is the ratio of the Exports(as % of merchandise exports) in 1965 in Portugal to that in Singapore?
Ensure brevity in your answer.  0.07. What is the ratio of the Exports(as % of merchandise exports) of 1962 in Portugal to that in Spain?
Make the answer very short. 0.25. What is the ratio of the Exports(as % of merchandise exports) in 1963 in Portugal to that in Spain?
Your answer should be compact. 0.33. What is the ratio of the Exports(as % of merchandise exports) of 1964 in Portugal to that in Spain?
Offer a very short reply. 0.35. What is the ratio of the Exports(as % of merchandise exports) of 1965 in Portugal to that in Spain?
Offer a terse response. 0.37. What is the ratio of the Exports(as % of merchandise exports) in 1962 in Singapore to that in Spain?
Keep it short and to the point. 2.82. What is the ratio of the Exports(as % of merchandise exports) in 1963 in Singapore to that in Spain?
Your answer should be very brief. 2.88. What is the ratio of the Exports(as % of merchandise exports) in 1964 in Singapore to that in Spain?
Ensure brevity in your answer.  3.66. What is the ratio of the Exports(as % of merchandise exports) in 1965 in Singapore to that in Spain?
Make the answer very short. 5.06. What is the difference between the highest and the second highest Exports(as % of merchandise exports) of 1962?
Give a very brief answer. 11.45. What is the difference between the highest and the second highest Exports(as % of merchandise exports) in 1963?
Your response must be concise. 31.77. What is the difference between the highest and the second highest Exports(as % of merchandise exports) of 1964?
Give a very brief answer. 22.67. What is the difference between the highest and the second highest Exports(as % of merchandise exports) of 1965?
Keep it short and to the point. 13.88. What is the difference between the highest and the lowest Exports(as % of merchandise exports) in 1962?
Your answer should be compact. 34.65. What is the difference between the highest and the lowest Exports(as % of merchandise exports) in 1963?
Provide a succinct answer. 48.22. What is the difference between the highest and the lowest Exports(as % of merchandise exports) in 1964?
Your answer should be very brief. 40.41. What is the difference between the highest and the lowest Exports(as % of merchandise exports) in 1965?
Offer a very short reply. 33.06. 